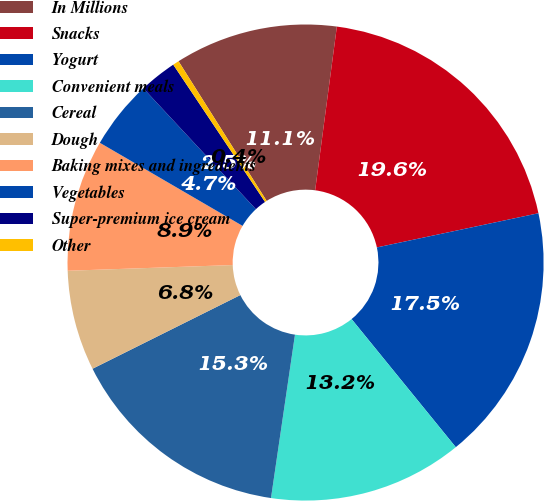Convert chart. <chart><loc_0><loc_0><loc_500><loc_500><pie_chart><fcel>In Millions<fcel>Snacks<fcel>Yogurt<fcel>Convenient meals<fcel>Cereal<fcel>Dough<fcel>Baking mixes and ingredients<fcel>Vegetables<fcel>Super-premium ice cream<fcel>Other<nl><fcel>11.06%<fcel>19.58%<fcel>17.45%<fcel>13.19%<fcel>15.32%<fcel>6.81%<fcel>8.94%<fcel>4.68%<fcel>2.55%<fcel>0.42%<nl></chart> 